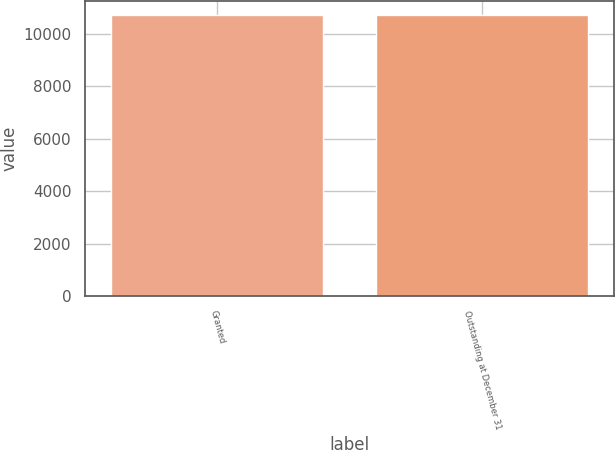Convert chart to OTSL. <chart><loc_0><loc_0><loc_500><loc_500><bar_chart><fcel>Granted<fcel>Outstanding at December 31<nl><fcel>10705<fcel>10705.1<nl></chart> 